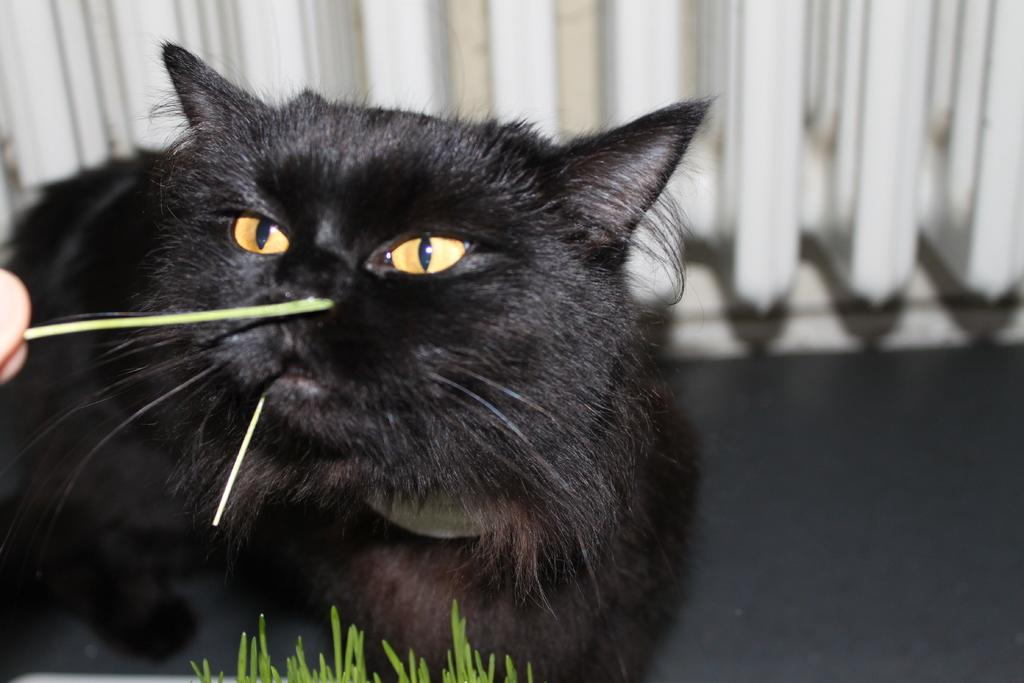What animal is located in the middle of the image? There is a black cat in the middle of the image. What type of vegetation is at the bottom of the image? There is grass at the bottom of the image. What part of a person's body is visible on the left side of the image? A person's finger is visible on the left side of the image. What color is the object at the top of the image? There is a white color object at the top of the image. Where is the alley located in the image? There is no alley present in the image. Can you describe the floor in the image? There is no floor visible in the image; it features a black cat, grass, a person's finger, and a white object. 